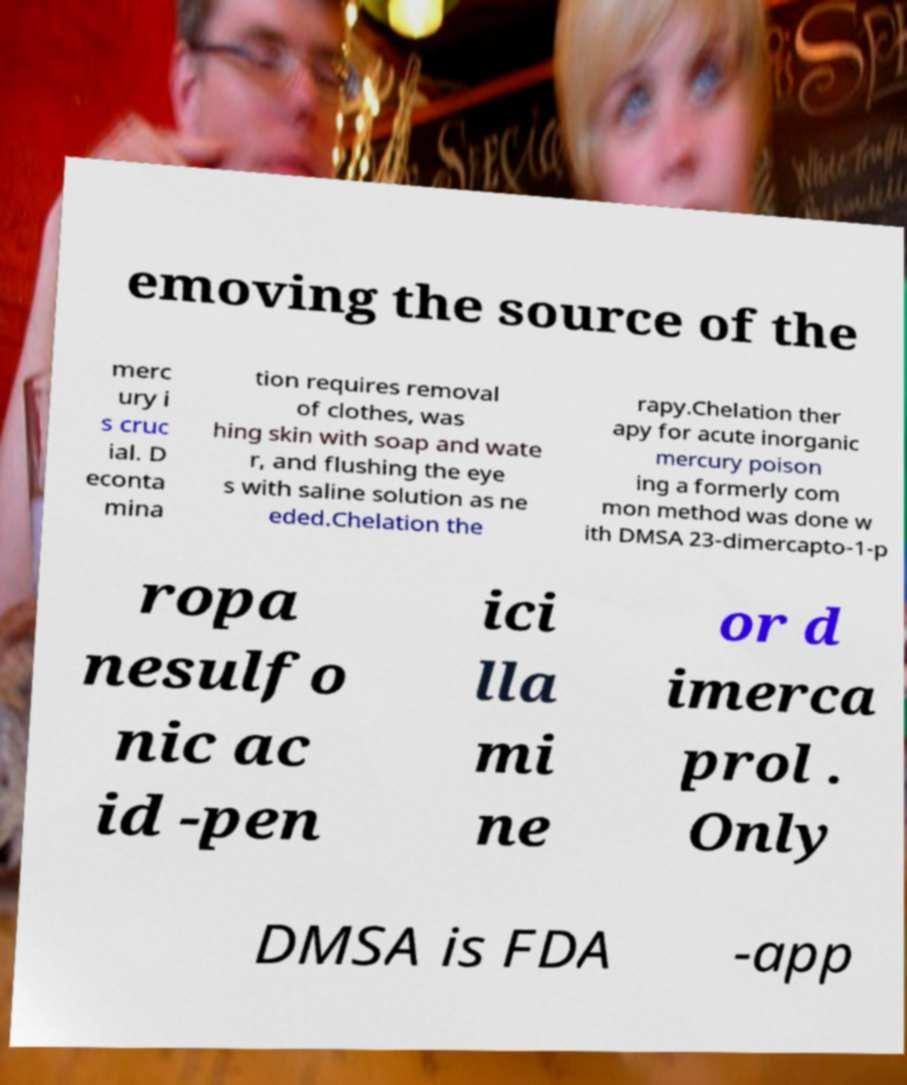Could you extract and type out the text from this image? emoving the source of the merc ury i s cruc ial. D econta mina tion requires removal of clothes, was hing skin with soap and wate r, and flushing the eye s with saline solution as ne eded.Chelation the rapy.Chelation ther apy for acute inorganic mercury poison ing a formerly com mon method was done w ith DMSA 23-dimercapto-1-p ropa nesulfo nic ac id -pen ici lla mi ne or d imerca prol . Only DMSA is FDA -app 